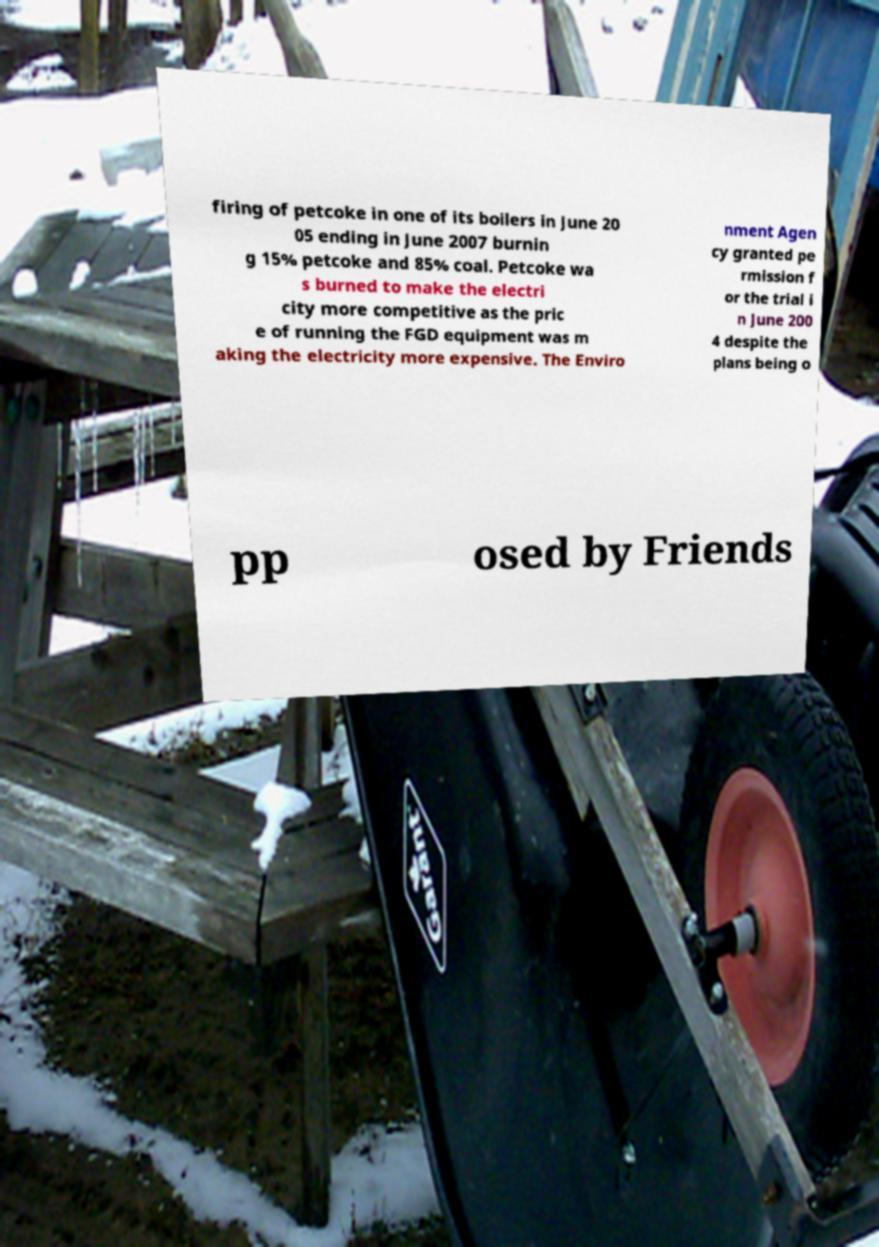For documentation purposes, I need the text within this image transcribed. Could you provide that? firing of petcoke in one of its boilers in June 20 05 ending in June 2007 burnin g 15% petcoke and 85% coal. Petcoke wa s burned to make the electri city more competitive as the pric e of running the FGD equipment was m aking the electricity more expensive. The Enviro nment Agen cy granted pe rmission f or the trial i n June 200 4 despite the plans being o pp osed by Friends 